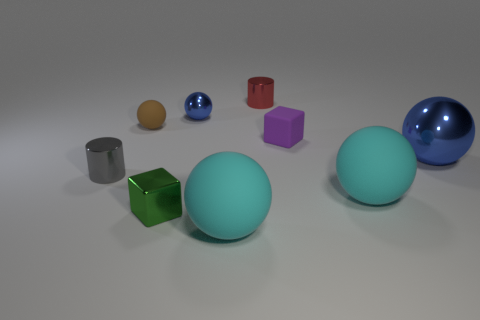Add 1 brown rubber things. How many objects exist? 10 Subtract all large blue metal balls. How many balls are left? 4 Subtract all gray blocks. How many cyan spheres are left? 2 Subtract all cubes. How many objects are left? 7 Subtract all cyan cubes. Subtract all purple matte cubes. How many objects are left? 8 Add 5 tiny metallic cylinders. How many tiny metallic cylinders are left? 7 Add 8 blue things. How many blue things exist? 10 Subtract all brown balls. How many balls are left? 4 Subtract 0 gray spheres. How many objects are left? 9 Subtract 1 blocks. How many blocks are left? 1 